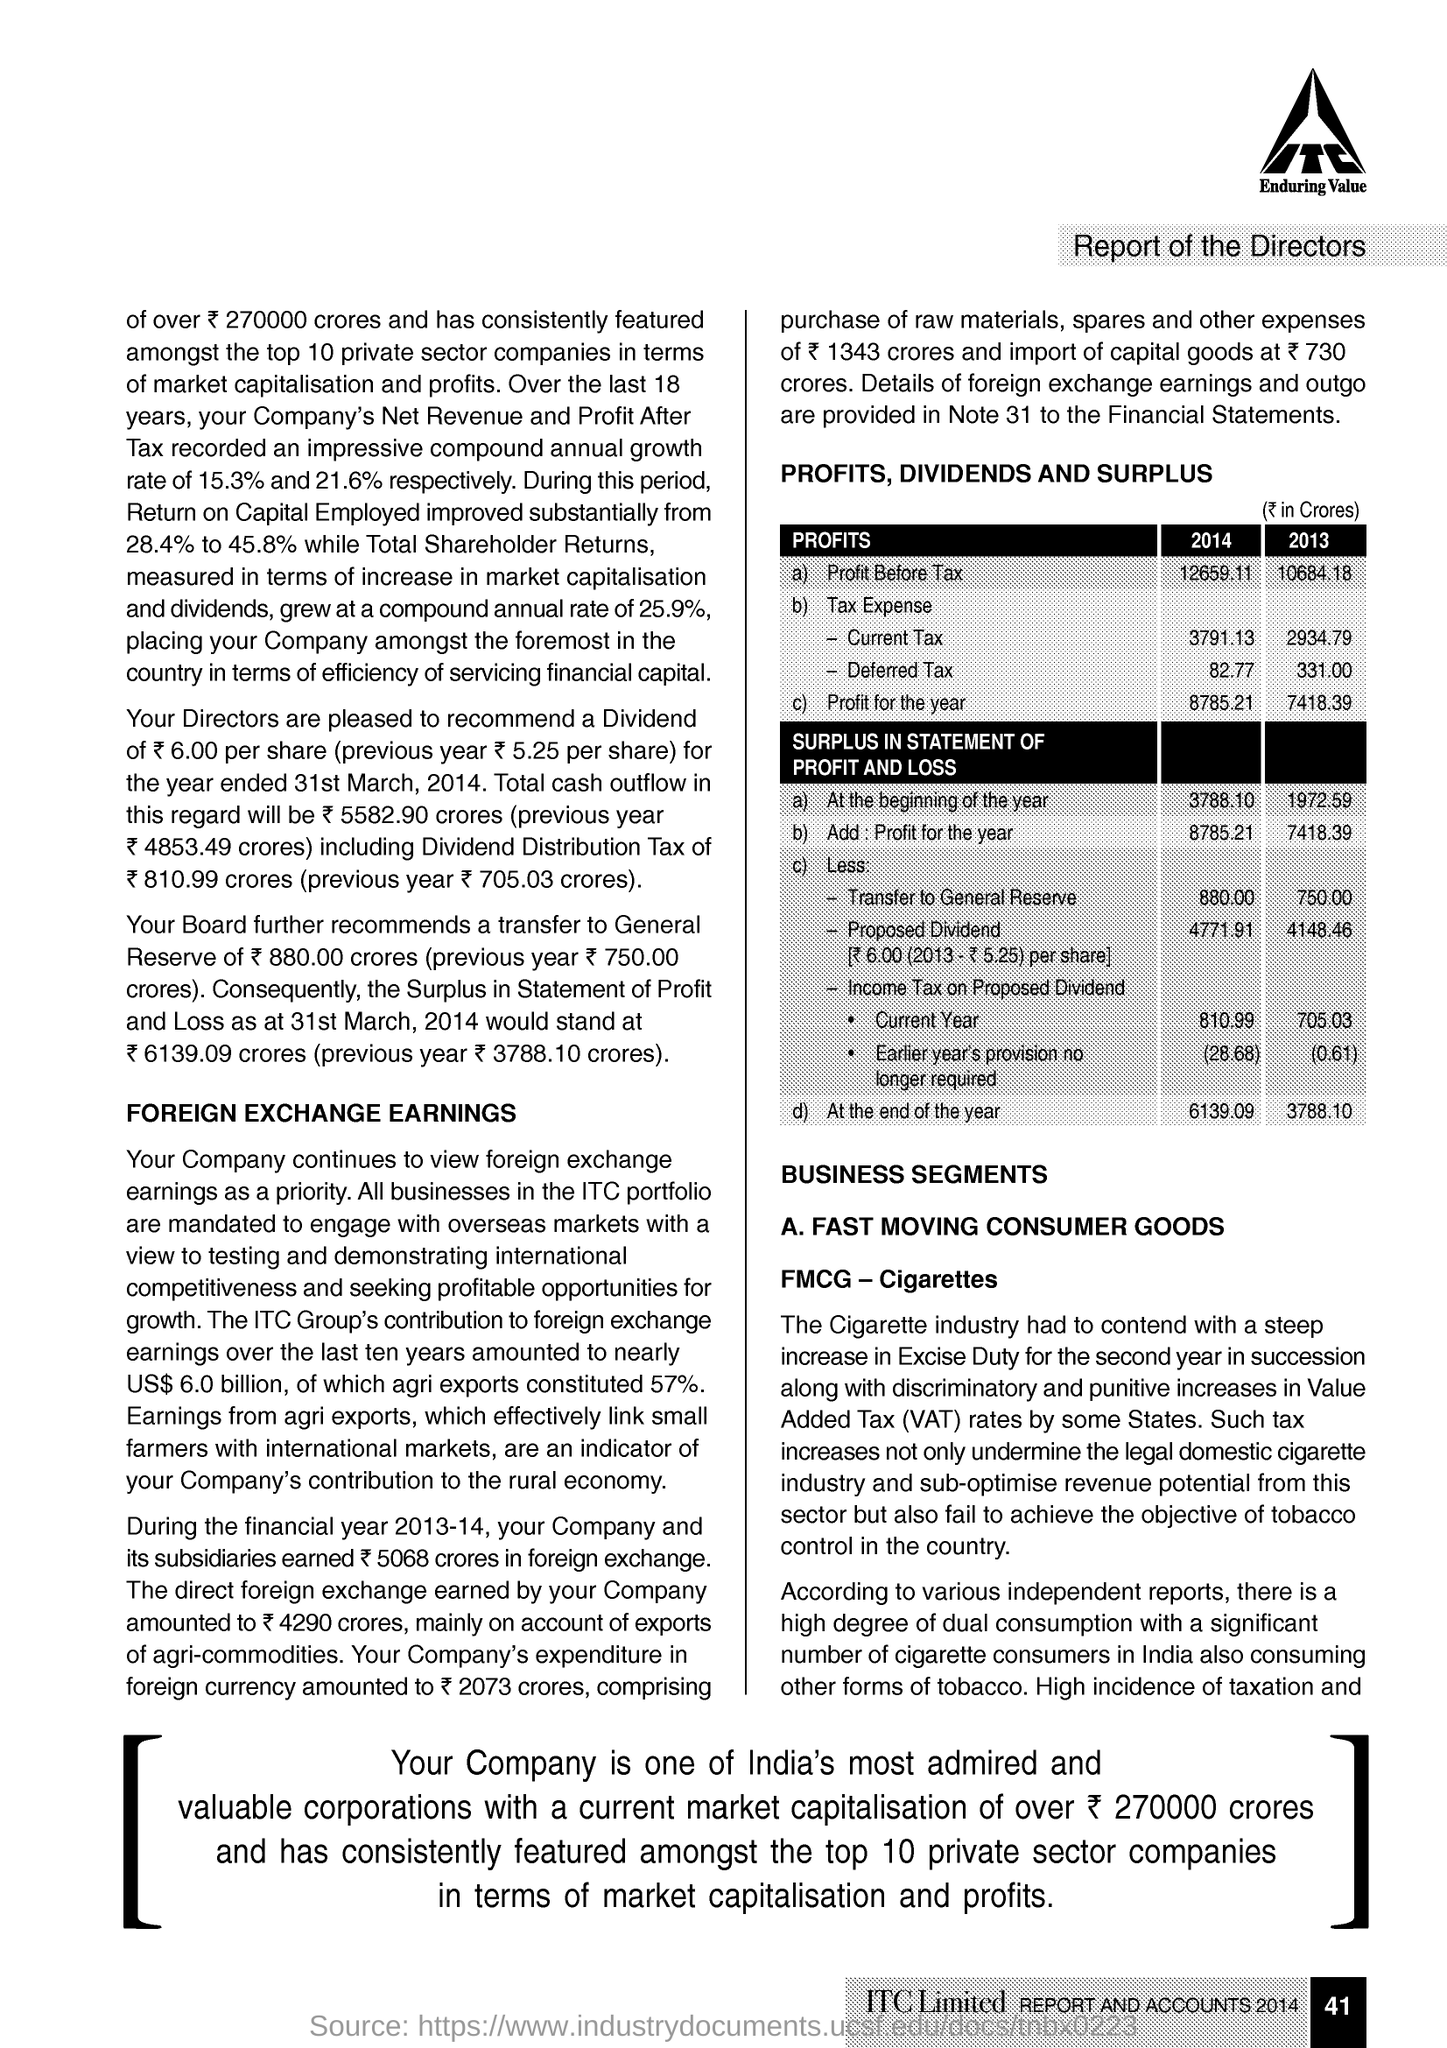Indicate a few pertinent items in this graphic. Value Added Tax (VAT) is a tax on goods and services that is added to the price at each stage of production and distribution, ultimately being paid by the consumer. Fast Moving Consumer Goods (FMCG) is a term used to describe a broad category of everyday items that are consumed quickly and typically have a high turnover rate. These goods include items such as food and beverages, personal care products, and household items. The profit before tax in 2014 was 12659.11. The profit for the year in 2013 was 7,418.39. 